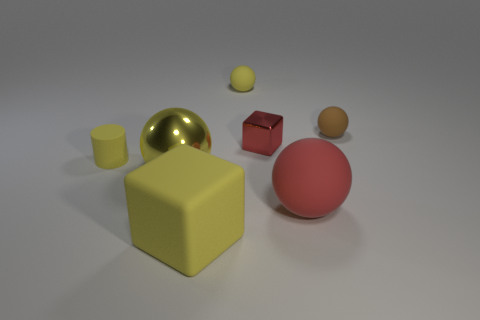Subtract all large rubber balls. How many balls are left? 3 Add 3 large yellow things. How many objects exist? 10 Subtract all red balls. How many balls are left? 3 Subtract all cubes. How many objects are left? 5 Add 4 green things. How many green things exist? 4 Subtract 1 yellow cubes. How many objects are left? 6 Subtract all brown blocks. Subtract all green cylinders. How many blocks are left? 2 Subtract all green spheres. How many yellow cubes are left? 1 Subtract all large cyan metal balls. Subtract all large yellow spheres. How many objects are left? 6 Add 4 tiny blocks. How many tiny blocks are left? 5 